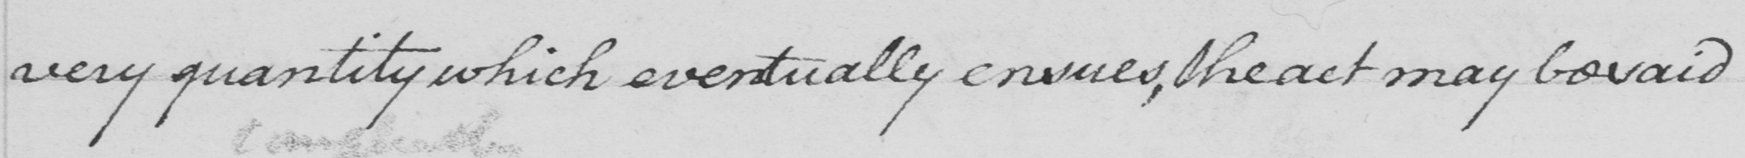What does this handwritten line say? very quantity which eventually ensues, the act may be said 